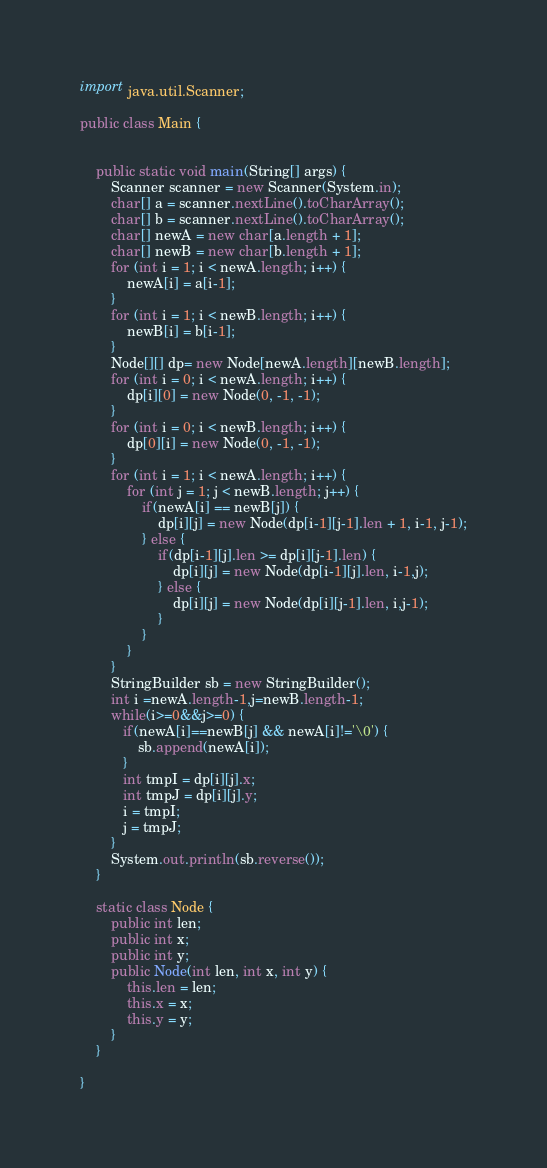Convert code to text. <code><loc_0><loc_0><loc_500><loc_500><_Java_>import java.util.Scanner;

public class Main {


    public static void main(String[] args) {
        Scanner scanner = new Scanner(System.in);
        char[] a = scanner.nextLine().toCharArray();
        char[] b = scanner.nextLine().toCharArray();
        char[] newA = new char[a.length + 1];
        char[] newB = new char[b.length + 1];
        for (int i = 1; i < newA.length; i++) {
            newA[i] = a[i-1];
        }
        for (int i = 1; i < newB.length; i++) {
            newB[i] = b[i-1];
        }
        Node[][] dp= new Node[newA.length][newB.length];
        for (int i = 0; i < newA.length; i++) {
            dp[i][0] = new Node(0, -1, -1);
        }
        for (int i = 0; i < newB.length; i++) {
            dp[0][i] = new Node(0, -1, -1);
        }
        for (int i = 1; i < newA.length; i++) {
            for (int j = 1; j < newB.length; j++) {
                if(newA[i] == newB[j]) {
                    dp[i][j] = new Node(dp[i-1][j-1].len + 1, i-1, j-1);
                } else {
                    if(dp[i-1][j].len >= dp[i][j-1].len) {
                        dp[i][j] = new Node(dp[i-1][j].len, i-1,j);
                    } else {
                        dp[i][j] = new Node(dp[i][j-1].len, i,j-1);
                    }
                }
            }
        }
        StringBuilder sb = new StringBuilder();
        int i =newA.length-1,j=newB.length-1;
        while(i>=0&&j>=0) {
           if(newA[i]==newB[j] && newA[i]!='\0') {
               sb.append(newA[i]);
           }
           int tmpI = dp[i][j].x;
           int tmpJ = dp[i][j].y;
           i = tmpI;
           j = tmpJ;
        }
        System.out.println(sb.reverse());
    }

    static class Node {
        public int len;
        public int x;
        public int y;
        public Node(int len, int x, int y) {
            this.len = len;
            this.x = x;
            this.y = y;
        }
    }

}</code> 